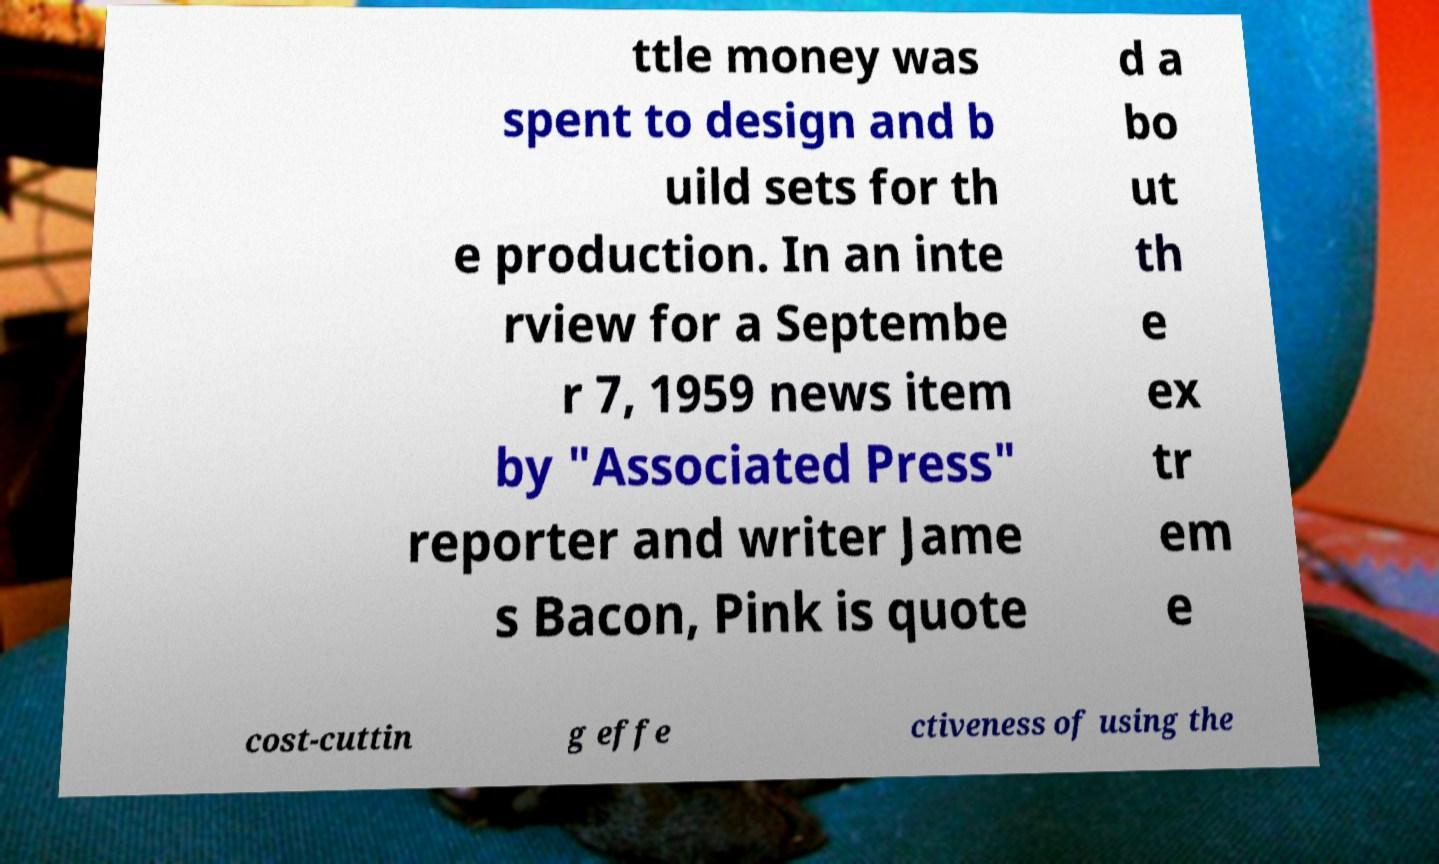Please identify and transcribe the text found in this image. ttle money was spent to design and b uild sets for th e production. In an inte rview for a Septembe r 7, 1959 news item by "Associated Press" reporter and writer Jame s Bacon, Pink is quote d a bo ut th e ex tr em e cost-cuttin g effe ctiveness of using the 